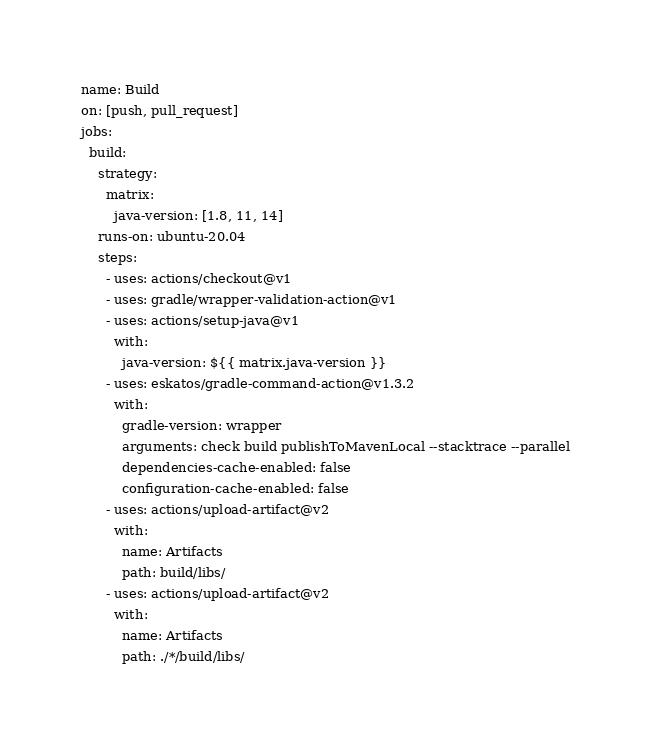<code> <loc_0><loc_0><loc_500><loc_500><_YAML_>name: Build
on: [push, pull_request]
jobs:
  build:
    strategy:
      matrix:
        java-version: [1.8, 11, 14]
    runs-on: ubuntu-20.04
    steps:
      - uses: actions/checkout@v1
      - uses: gradle/wrapper-validation-action@v1
      - uses: actions/setup-java@v1
        with:
          java-version: ${{ matrix.java-version }}
      - uses: eskatos/gradle-command-action@v1.3.2
        with:
          gradle-version: wrapper
          arguments: check build publishToMavenLocal --stacktrace --parallel
          dependencies-cache-enabled: false
          configuration-cache-enabled: false
      - uses: actions/upload-artifact@v2
        with:
          name: Artifacts
          path: build/libs/
      - uses: actions/upload-artifact@v2
        with:
          name: Artifacts
          path: ./*/build/libs/
</code> 